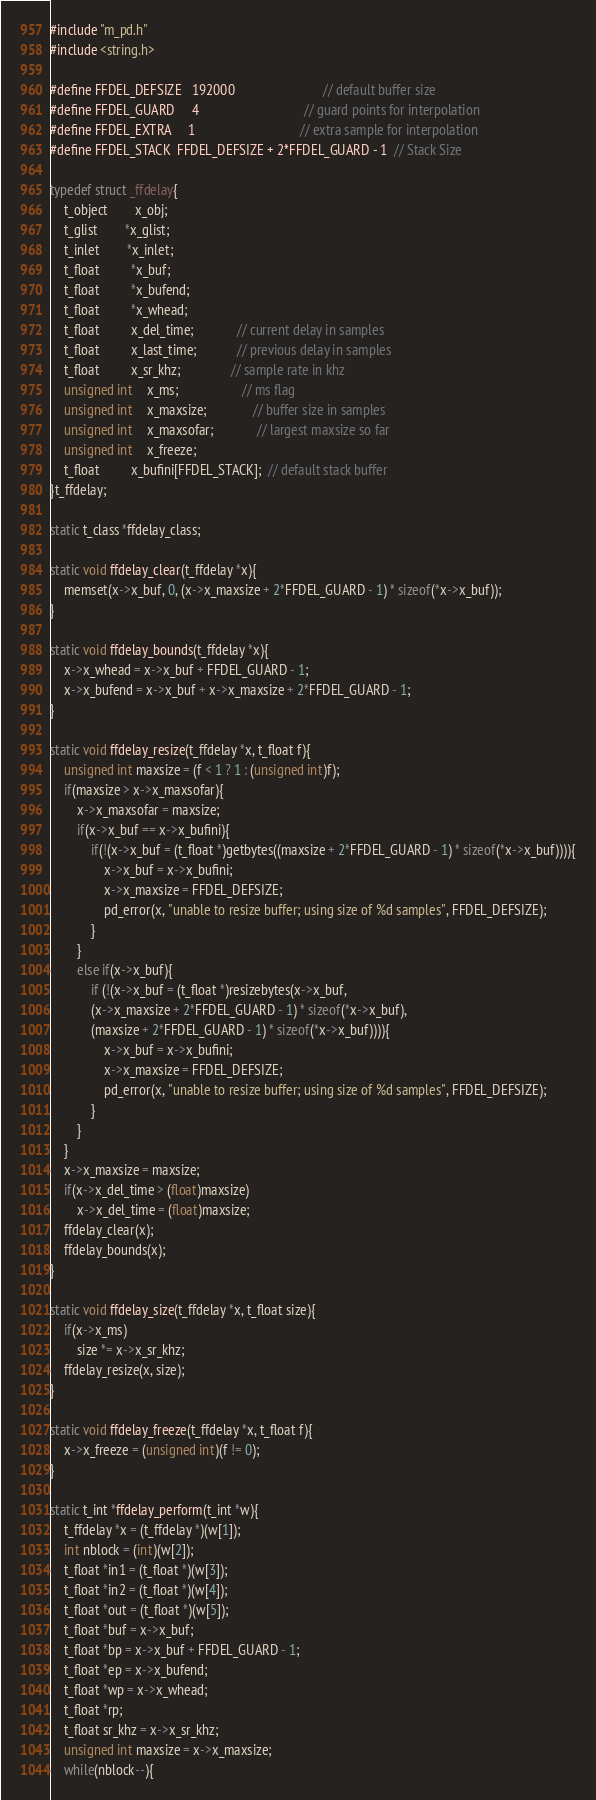Convert code to text. <code><loc_0><loc_0><loc_500><loc_500><_C_>#include "m_pd.h"
#include <string.h>

#define FFDEL_DEFSIZE   192000                          // default buffer size
#define FFDEL_GUARD     4                               // guard points for interpolation
#define FFDEL_EXTRA     1                               // extra sample for interpolation
#define FFDEL_STACK  FFDEL_DEFSIZE + 2*FFDEL_GUARD - 1  // Stack Size

typedef struct _ffdelay{
    t_object        x_obj;
    t_glist        *x_glist;
    t_inlet        *x_inlet;
    t_float         *x_buf;
    t_float         *x_bufend;
    t_float         *x_whead;
    t_float         x_del_time;             // current delay in samples
    t_float         x_last_time;            // previous delay in samples
    t_float         x_sr_khz;               // sample rate in khz
    unsigned int    x_ms;                   // ms flag
    unsigned int	x_maxsize;              // buffer size in samples
    unsigned int	x_maxsofar;             // largest maxsize so far
    unsigned int    x_freeze;
    t_float         x_bufini[FFDEL_STACK];  // default stack buffer
}t_ffdelay;

static t_class *ffdelay_class;

static void ffdelay_clear(t_ffdelay *x){
    memset(x->x_buf, 0, (x->x_maxsize + 2*FFDEL_GUARD - 1) * sizeof(*x->x_buf));
}

static void ffdelay_bounds(t_ffdelay *x){
    x->x_whead = x->x_buf + FFDEL_GUARD - 1;
    x->x_bufend = x->x_buf + x->x_maxsize + 2*FFDEL_GUARD - 1;
}

static void ffdelay_resize(t_ffdelay *x, t_float f){
    unsigned int maxsize = (f < 1 ? 1 : (unsigned int)f);
    if(maxsize > x->x_maxsofar){
        x->x_maxsofar = maxsize;
        if(x->x_buf == x->x_bufini){
            if(!(x->x_buf = (t_float *)getbytes((maxsize + 2*FFDEL_GUARD - 1) * sizeof(*x->x_buf)))){
                x->x_buf = x->x_bufini;
                x->x_maxsize = FFDEL_DEFSIZE;
                pd_error(x, "unable to resize buffer; using size of %d samples", FFDEL_DEFSIZE);
            }
        }
        else if(x->x_buf){
            if (!(x->x_buf = (t_float *)resizebytes(x->x_buf,
            (x->x_maxsize + 2*FFDEL_GUARD - 1) * sizeof(*x->x_buf),
            (maxsize + 2*FFDEL_GUARD - 1) * sizeof(*x->x_buf)))){
                x->x_buf = x->x_bufini;
                x->x_maxsize = FFDEL_DEFSIZE;
                pd_error(x, "unable to resize buffer; using size of %d samples", FFDEL_DEFSIZE);
            }		
        }
    }
    x->x_maxsize = maxsize;
    if(x->x_del_time > (float)maxsize)
        x->x_del_time = (float)maxsize;
    ffdelay_clear(x);
    ffdelay_bounds(x);
}

static void ffdelay_size(t_ffdelay *x, t_float size){
    if(x->x_ms)
        size *= x->x_sr_khz;
    ffdelay_resize(x, size);
}

static void ffdelay_freeze(t_ffdelay *x, t_float f){
    x->x_freeze = (unsigned int)(f != 0);
}

static t_int *ffdelay_perform(t_int *w){
	t_ffdelay *x = (t_ffdelay *)(w[1]);
    int nblock = (int)(w[2]);
    t_float *in1 = (t_float *)(w[3]);
    t_float *in2 = (t_float *)(w[4]);
    t_float *out = (t_float *)(w[5]);
    t_float *buf = x->x_buf;
    t_float *bp = x->x_buf + FFDEL_GUARD - 1;
    t_float *ep = x->x_bufend;
    t_float *wp = x->x_whead;
    t_float *rp;
    t_float sr_khz = x->x_sr_khz;
    unsigned int maxsize = x->x_maxsize;
    while(nblock--){</code> 